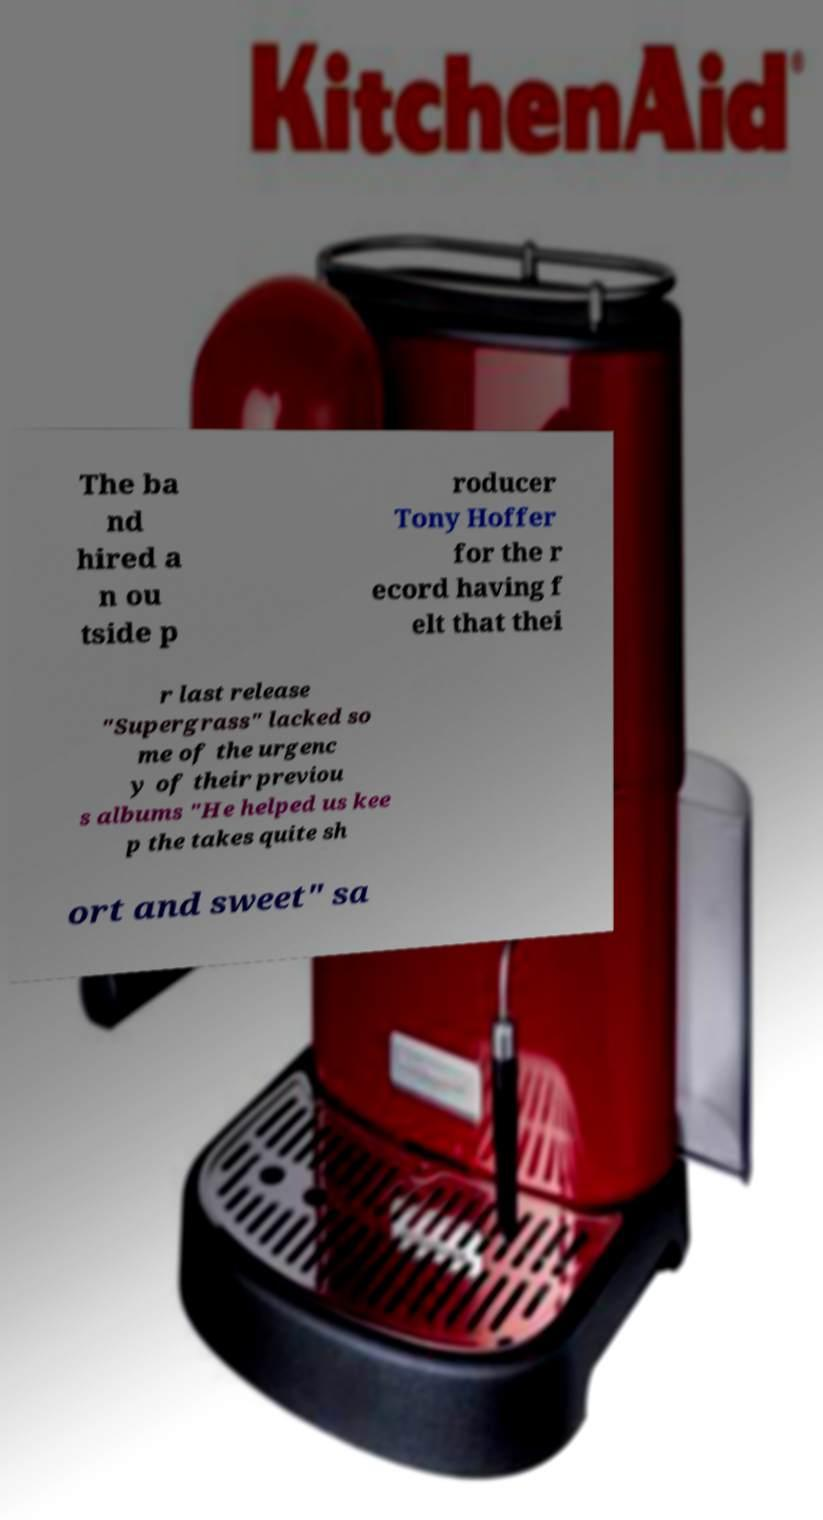Can you read and provide the text displayed in the image?This photo seems to have some interesting text. Can you extract and type it out for me? The ba nd hired a n ou tside p roducer Tony Hoffer for the r ecord having f elt that thei r last release "Supergrass" lacked so me of the urgenc y of their previou s albums "He helped us kee p the takes quite sh ort and sweet" sa 